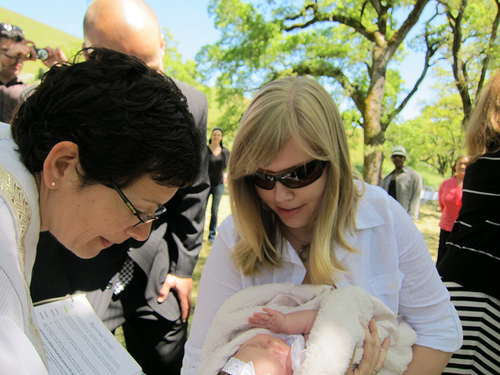<image>
Is the baby under the woman? Yes. The baby is positioned underneath the woman, with the woman above it in the vertical space. 